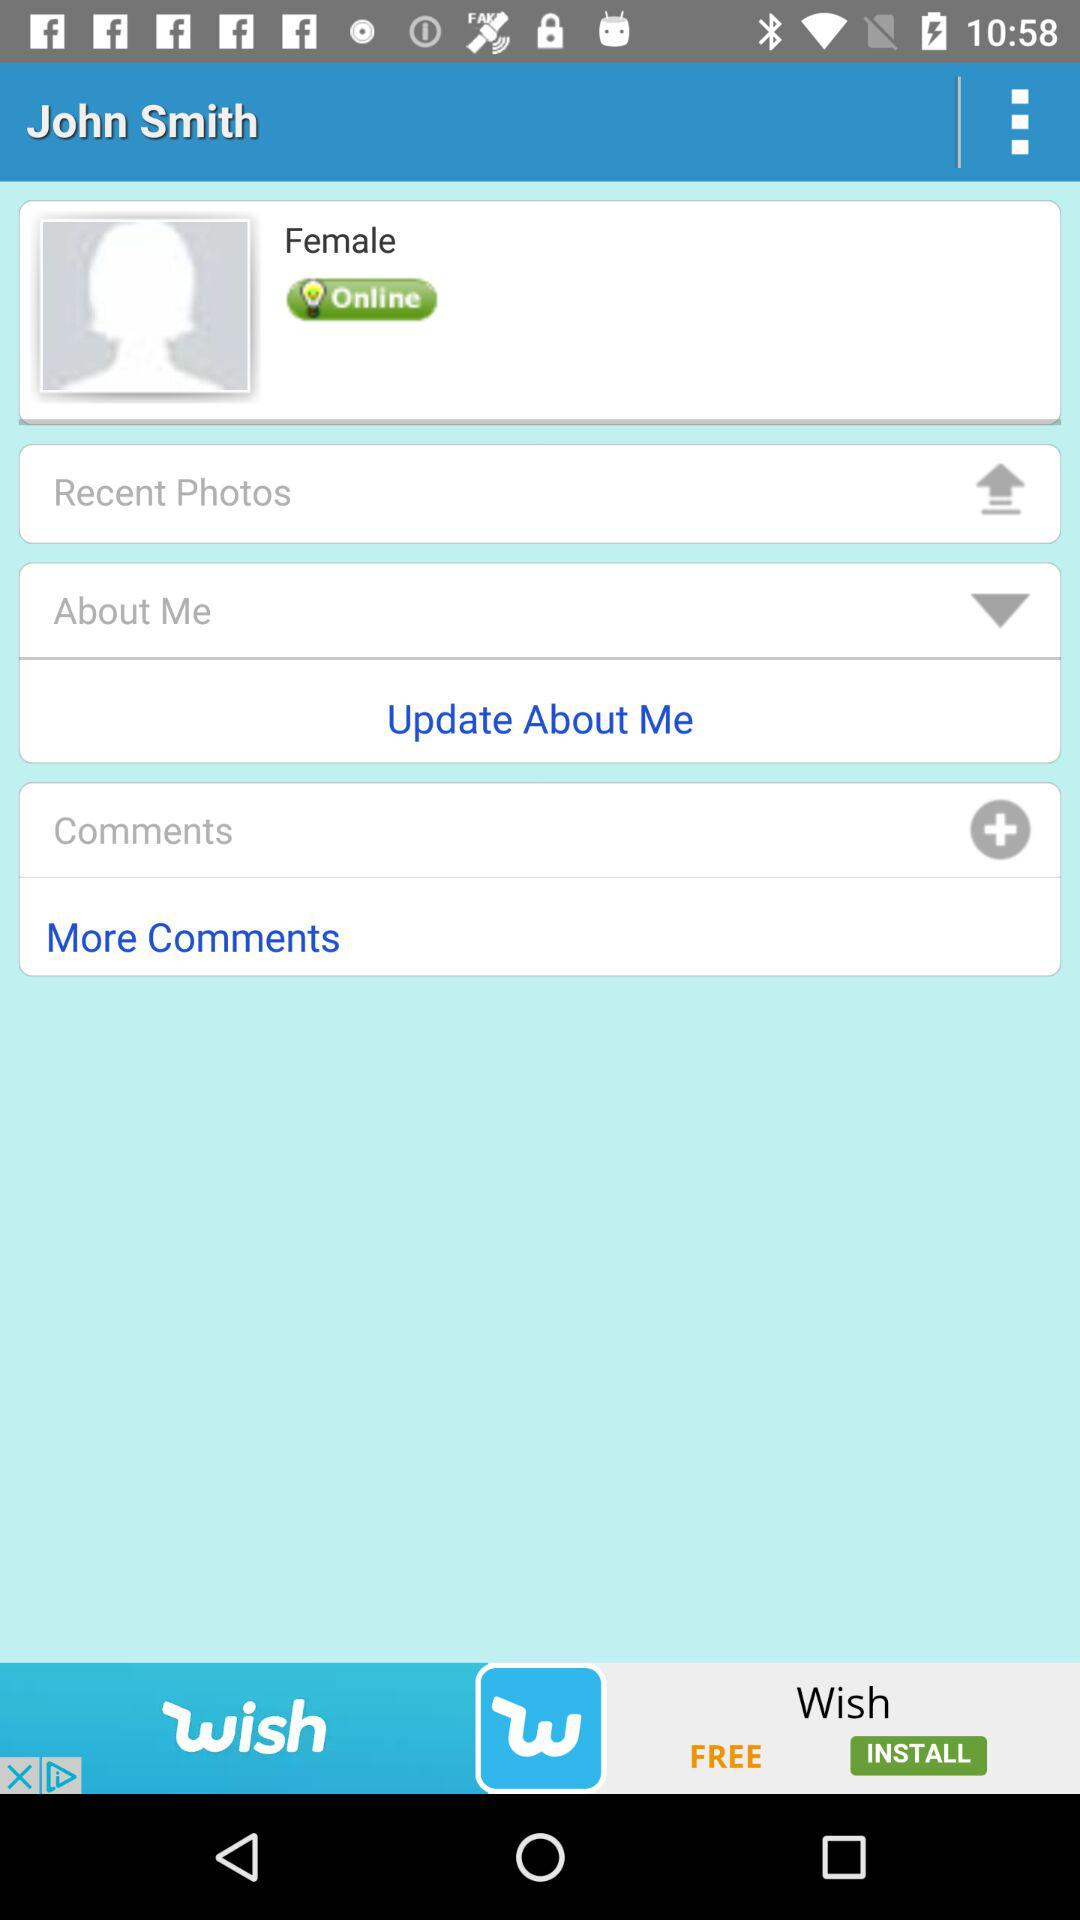What is the status? The status is "Online". 